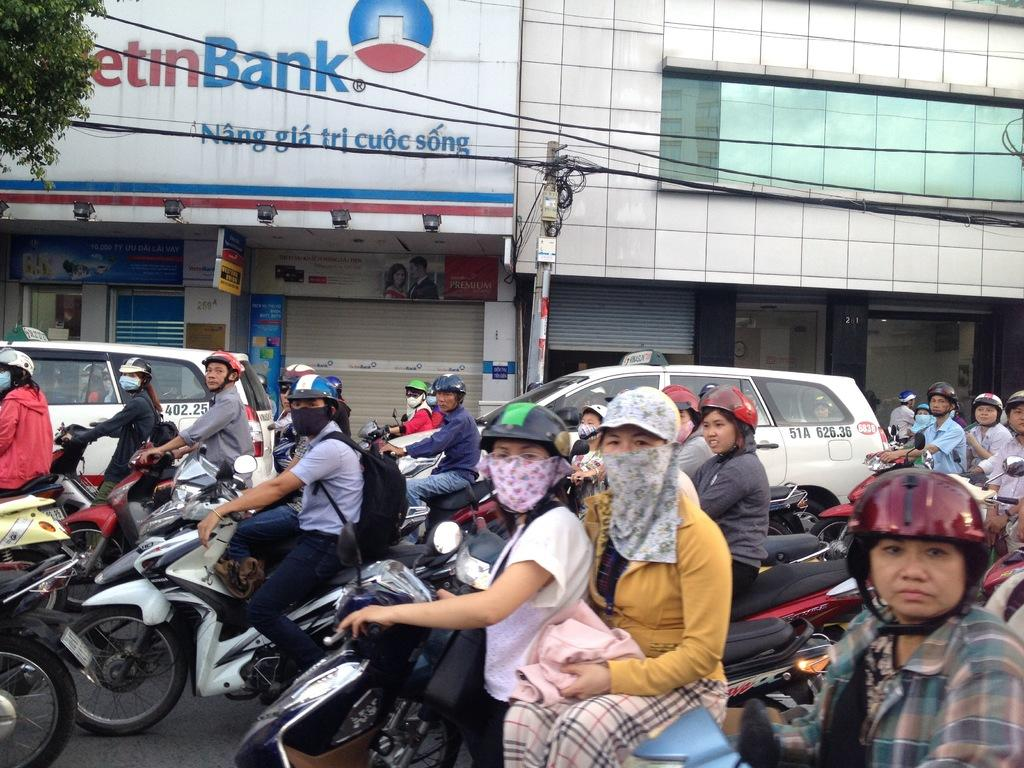What are the people in the image doing? There is a group of people riding bikes on the road in the image. What else can be seen on the road? Cars are visible in the image. What is the pole in the image used for? The purpose of the pole in the image is not specified, but it could be a utility pole or a traffic signal pole. What type of structures are visible in the image? There are buildings in the image. What other natural elements can be seen in the image? There are trees in the image. What type of fowl can be seen flying over the buildings in the image? There are no birds or fowl visible in the image. What is the tendency of the things in the image to move? The question about the "tendency of things to move" is too vague and cannot be answered definitively based on the provided facts. 